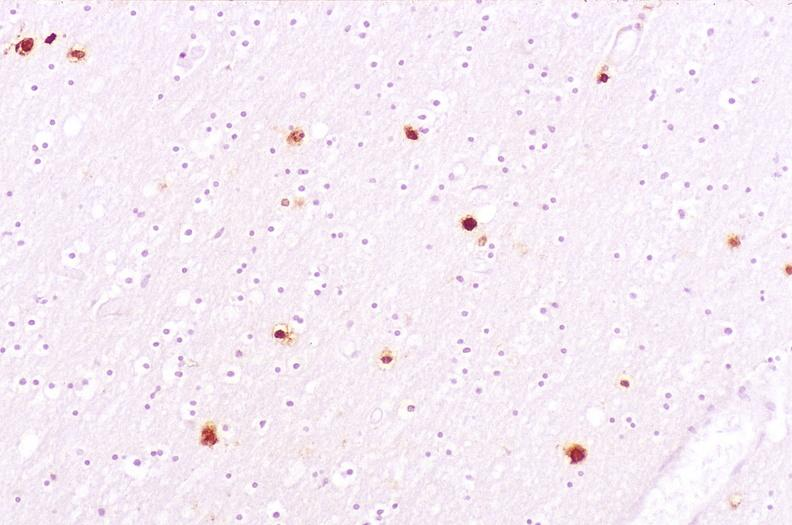s abdomen present?
Answer the question using a single word or phrase. No 